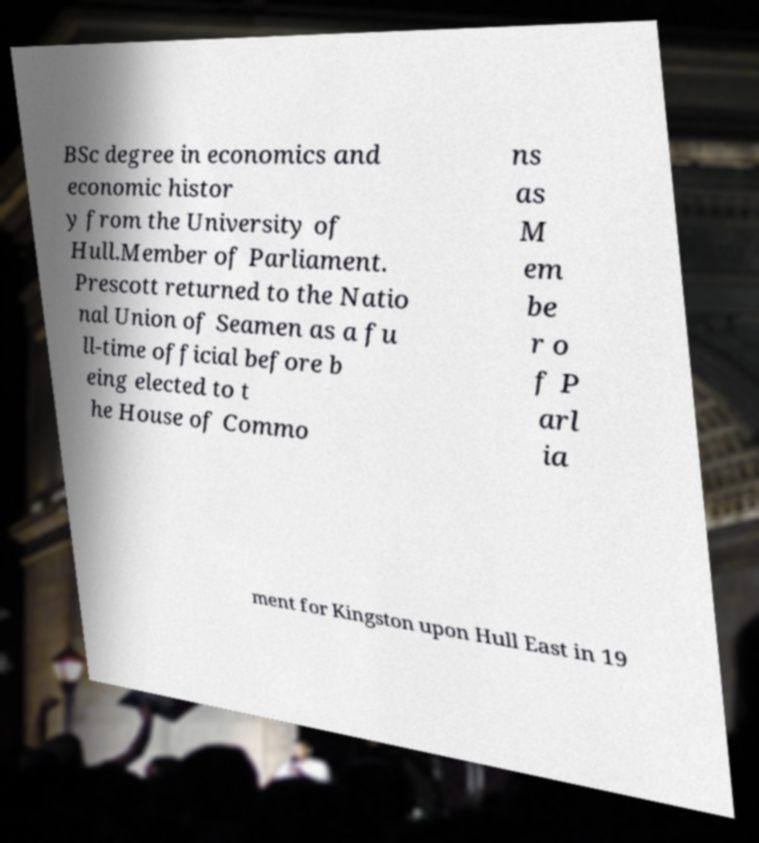Please read and relay the text visible in this image. What does it say? BSc degree in economics and economic histor y from the University of Hull.Member of Parliament. Prescott returned to the Natio nal Union of Seamen as a fu ll-time official before b eing elected to t he House of Commo ns as M em be r o f P arl ia ment for Kingston upon Hull East in 19 